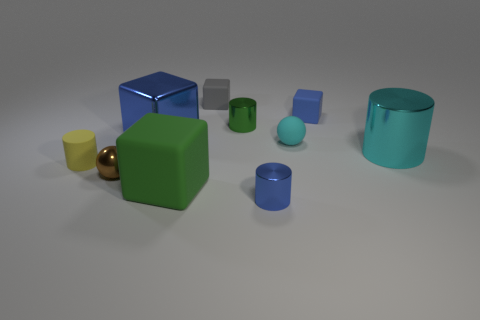Subtract all tiny blue cylinders. How many cylinders are left? 3 Subtract all gray cubes. How many cubes are left? 3 Subtract all blocks. How many objects are left? 6 Subtract 1 balls. How many balls are left? 1 Subtract 0 purple cubes. How many objects are left? 10 Subtract all green cylinders. Subtract all purple balls. How many cylinders are left? 3 Subtract all blue blocks. How many green cylinders are left? 1 Subtract all small yellow objects. Subtract all big green objects. How many objects are left? 8 Add 1 brown things. How many brown things are left? 2 Add 2 large cubes. How many large cubes exist? 4 